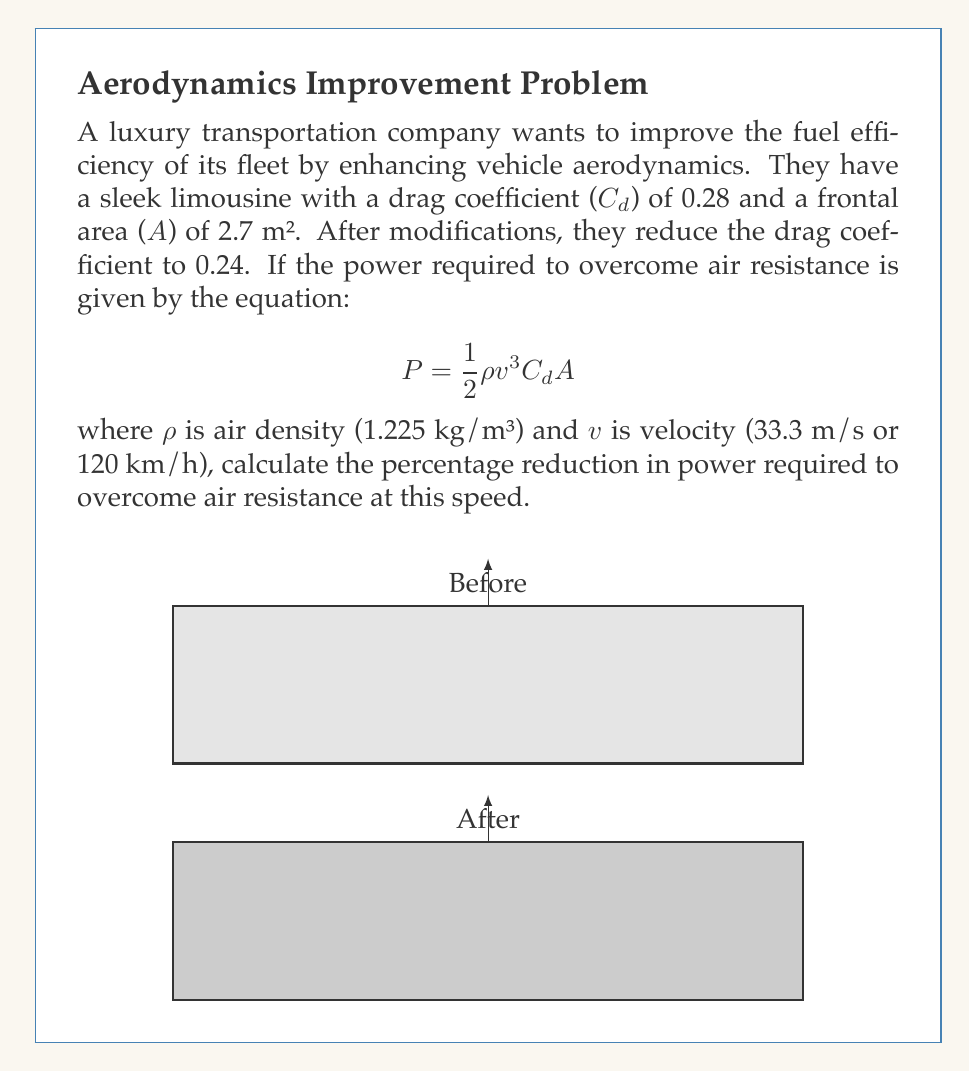What is the answer to this math problem? Let's approach this step-by-step:

1) We start with the given equation for power required to overcome air resistance:
   $$P = \frac{1}{2} \rho v^3 C_d A$$

2) We have two scenarios: before and after the modifications. Let's call them $P_1$ and $P_2$:
   $$P_1 = \frac{1}{2} \rho v^3 C_{d1} A$$
   $$P_2 = \frac{1}{2} \rho v^3 C_{d2} A$$

3) We're given:
   $\rho = 1.225$ kg/m³
   $v = 33.3$ m/s
   $A = 2.7$ m²
   $C_{d1} = 0.28$ (before)
   $C_{d2} = 0.24$ (after)

4) The only difference between $P_1$ and $P_2$ is the drag coefficient. So, we can calculate the ratio:
   $$\frac{P_2}{P_1} = \frac{C_{d2}}{C_{d1}} = \frac{0.24}{0.28} = 0.8571$$

5) This means $P_2$ is 85.71% of $P_1$. To find the percentage reduction:
   Reduction = (1 - 0.8571) × 100% = 14.29%

Therefore, the power required to overcome air resistance is reduced by 14.29%.
Answer: 14.29% 